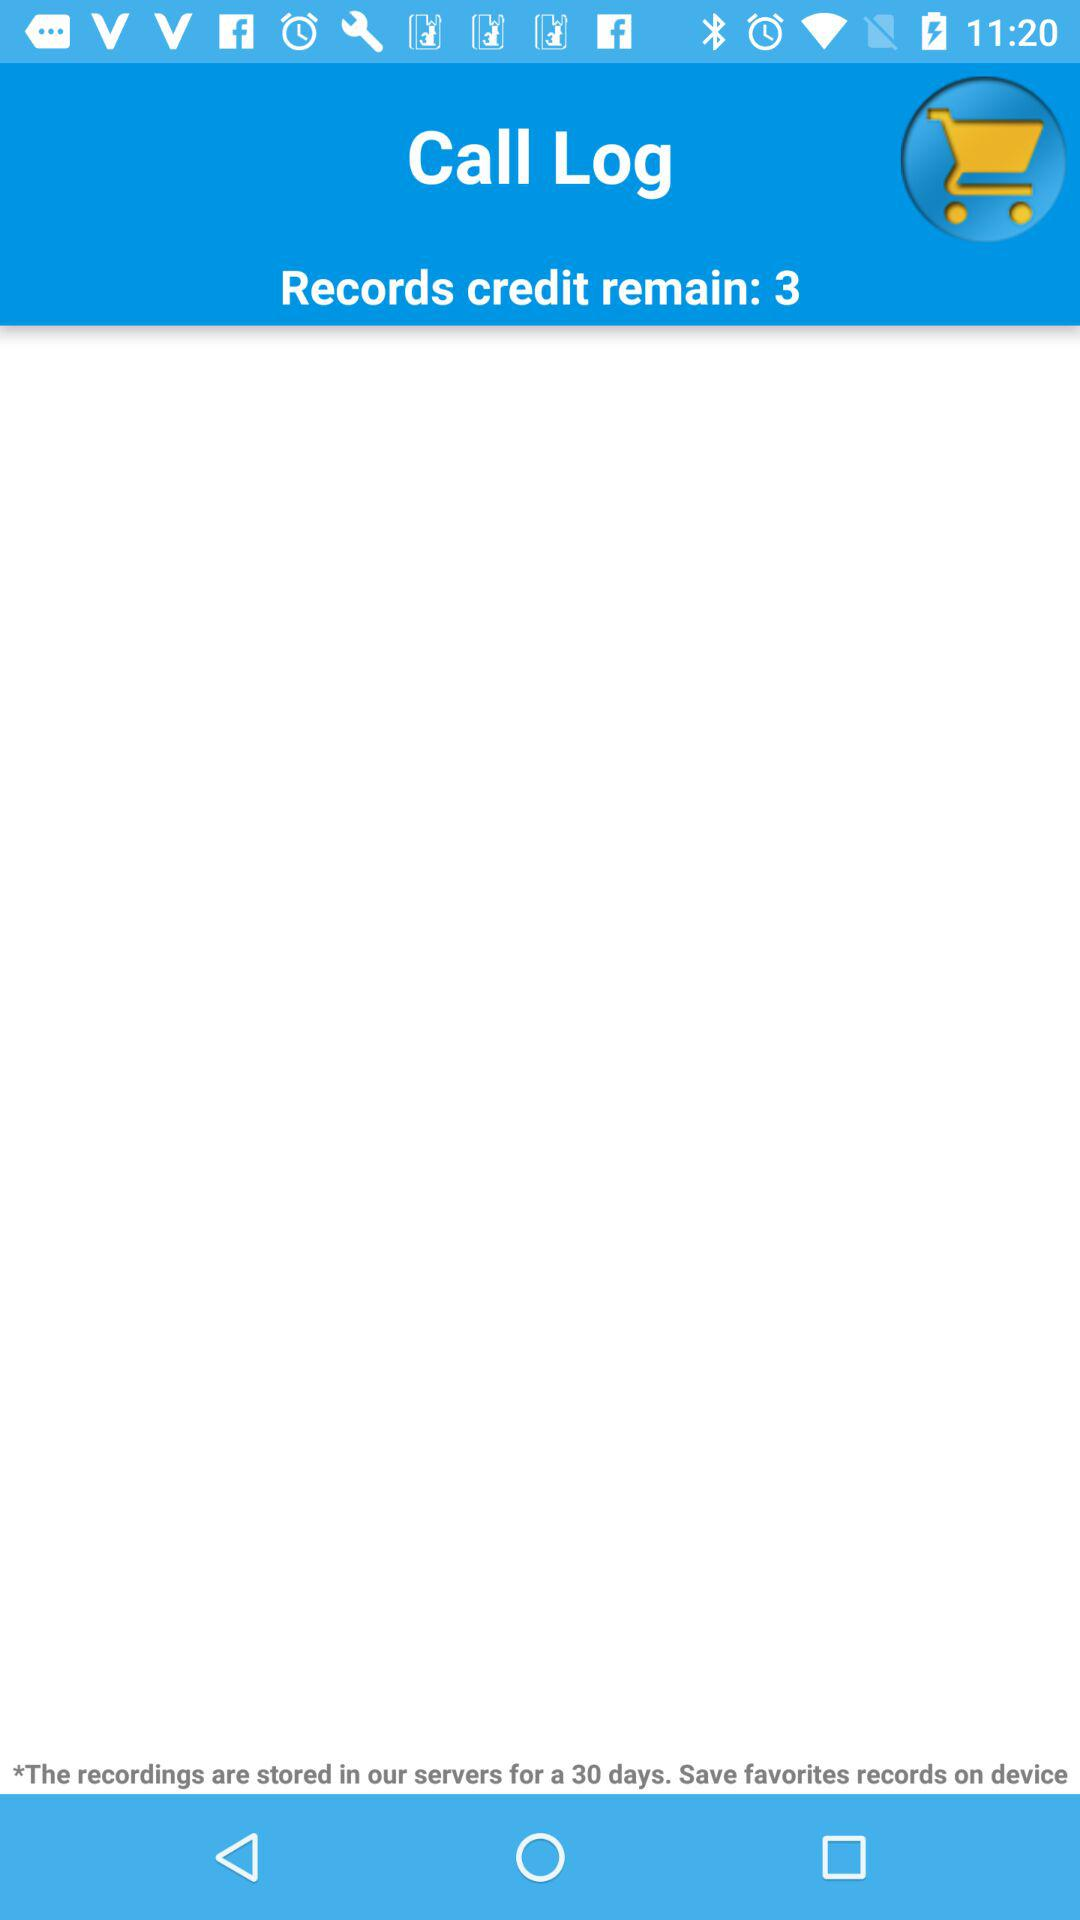How many record credits are remaining? There are 3 record credits remaining. 